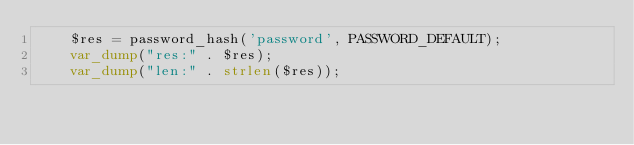Convert code to text. <code><loc_0><loc_0><loc_500><loc_500><_PHP_>    $res = password_hash('password', PASSWORD_DEFAULT);
    var_dump("res:" . $res);
    var_dump("len:" . strlen($res));
</code> 